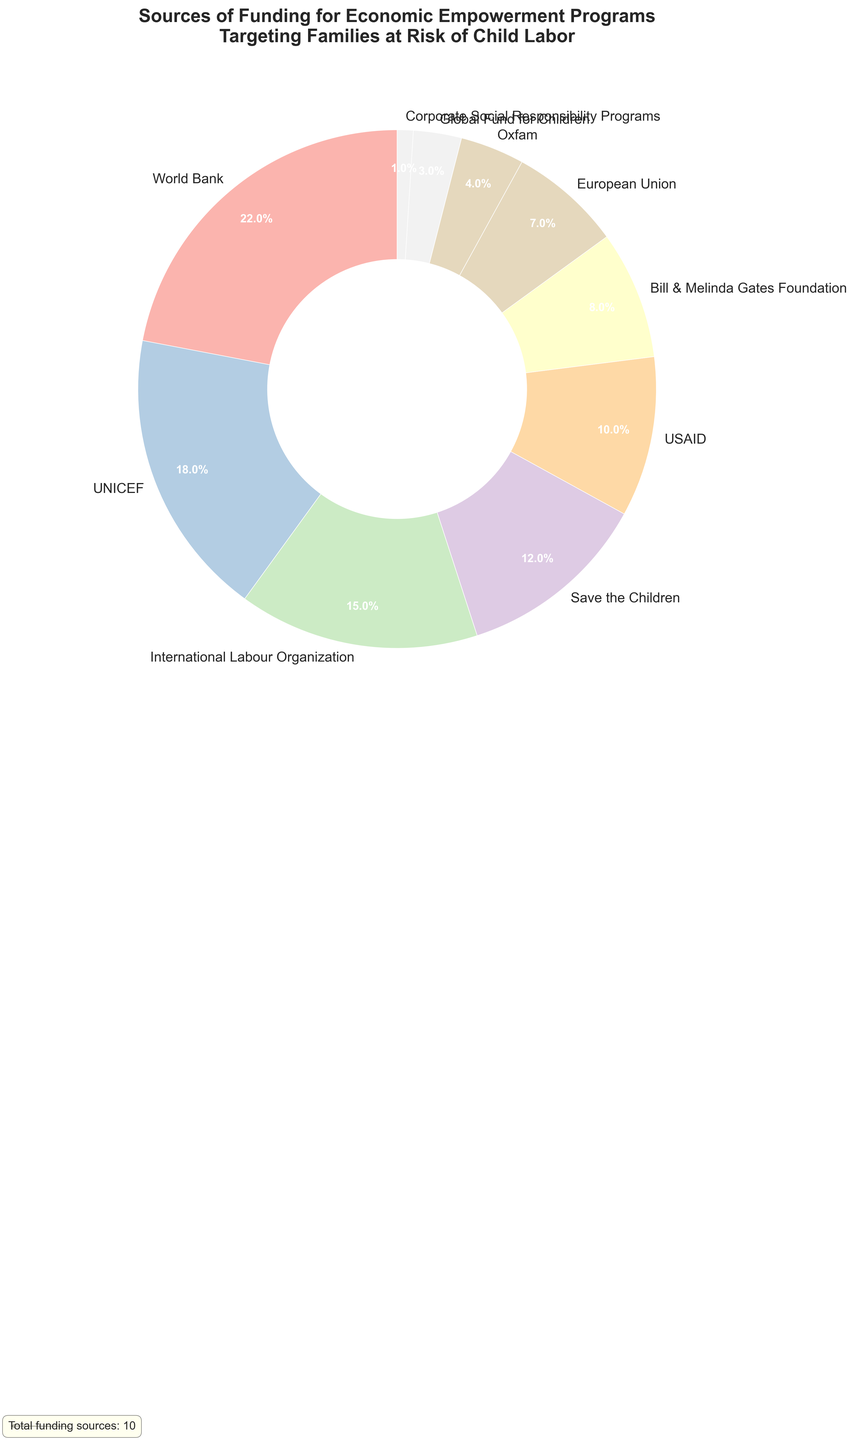What is the largest funding source for these economic empowerment programs? The largest funding source can be identified by the largest percentage slice in the pie chart. According to the data, the World Bank has the highest percentage at 22%.
Answer: World Bank Which funding source contributes more, UNICEF or Save the Children? To determine which contributes more, compare the percentages for each. UNICEF contributes 18%, while Save the Children contributes 12%, so UNICEF contributes more.
Answer: UNICEF How much more does the World Bank contribute compared to USAID? Subtract the percentage contribution of USAID from the World Bank. The World Bank contributes 22% and USAID contributes 10%. So, 22% - 10% = 12%.
Answer: 12% What is the combined contribution percentage of the International Labour Organization, Save the Children, and USAID? Add the percentages of these three sources together. International Labour Organization: 15%, Save the Children: 12%, USAID: 10%. Sum: 15% + 12% + 10% = 37%.
Answer: 37% Compare the contributions of the Bill & Melinda Gates Foundation and Oxfam. Which one provides less, and by how much? Compare the percentages of both sources. The Bill & Melinda Gates Foundation contributes 8% and Oxfam contributes 4%. The difference is 8% - 4% = 4%.
Answer: Oxfam provides less by 4% What is the total percentage contribution of non-governmental organizations (NGOs) provided in the data? Sum the percentages of Save the Children, Bill & Melinda Gates Foundation, Oxfam, and Global Fund for Children. Sum: 12% (Save the Children) + 8% (Bill & Melinda Gates Foundation) + 4% (Oxfam) + 3% (Global Fund for Children) = 27%.
Answer: 27% How does the contribution from Corporate Social Responsibility Programs compare to the contribution from the European Union? Compare the percentages for both sources. Corporate Social Responsibility Programs contribute 1%, while the European Union contributes 7%. So, Corporate Social Responsibility Programs contribute 6% less than the European Union.
Answer: 6% less Which funding sources provide at least a 10% contribution? From the data, identify sources with contributions of 10% or more. Those are the World Bank (22%), UNICEF (18%), International Labour Organization (15%), and Save the Children (12%).
Answer: World Bank, UNICEF, International Labour Organization, and Save the Children What is the difference in the percentage contribution between the top two contributors? The top two contributors are the World Bank (22%) and UNICEF (18%). The difference is calculated as 22% - 18% = 4%.
Answer: 4% 